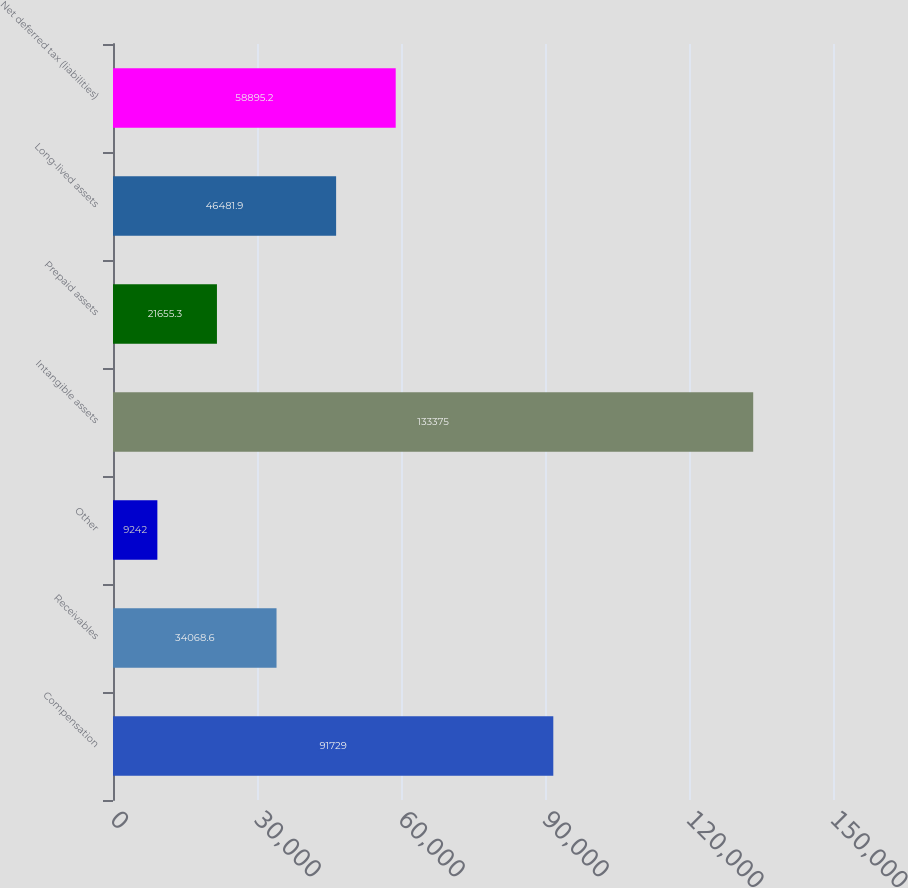<chart> <loc_0><loc_0><loc_500><loc_500><bar_chart><fcel>Compensation<fcel>Receivables<fcel>Other<fcel>Intangible assets<fcel>Prepaid assets<fcel>Long-lived assets<fcel>Net deferred tax (liabilities)<nl><fcel>91729<fcel>34068.6<fcel>9242<fcel>133375<fcel>21655.3<fcel>46481.9<fcel>58895.2<nl></chart> 